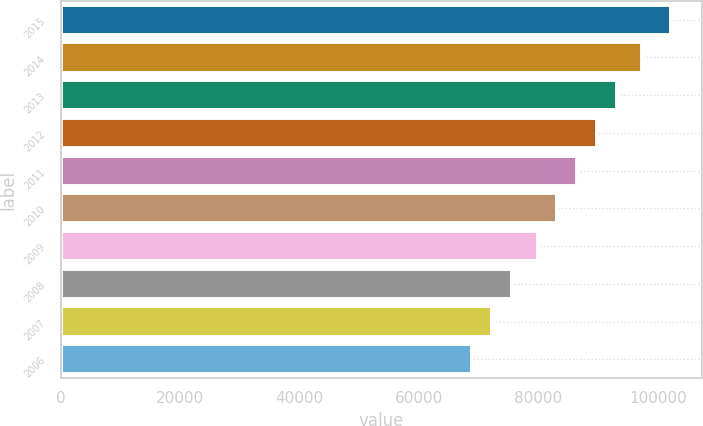<chart> <loc_0><loc_0><loc_500><loc_500><bar_chart><fcel>2015<fcel>2014<fcel>2013<fcel>2012<fcel>2011<fcel>2010<fcel>2009<fcel>2008<fcel>2007<fcel>2006<nl><fcel>102221<fcel>97406<fcel>93169.6<fcel>89842.7<fcel>86515.8<fcel>83188.9<fcel>79862<fcel>75605.8<fcel>72278.9<fcel>68952<nl></chart> 